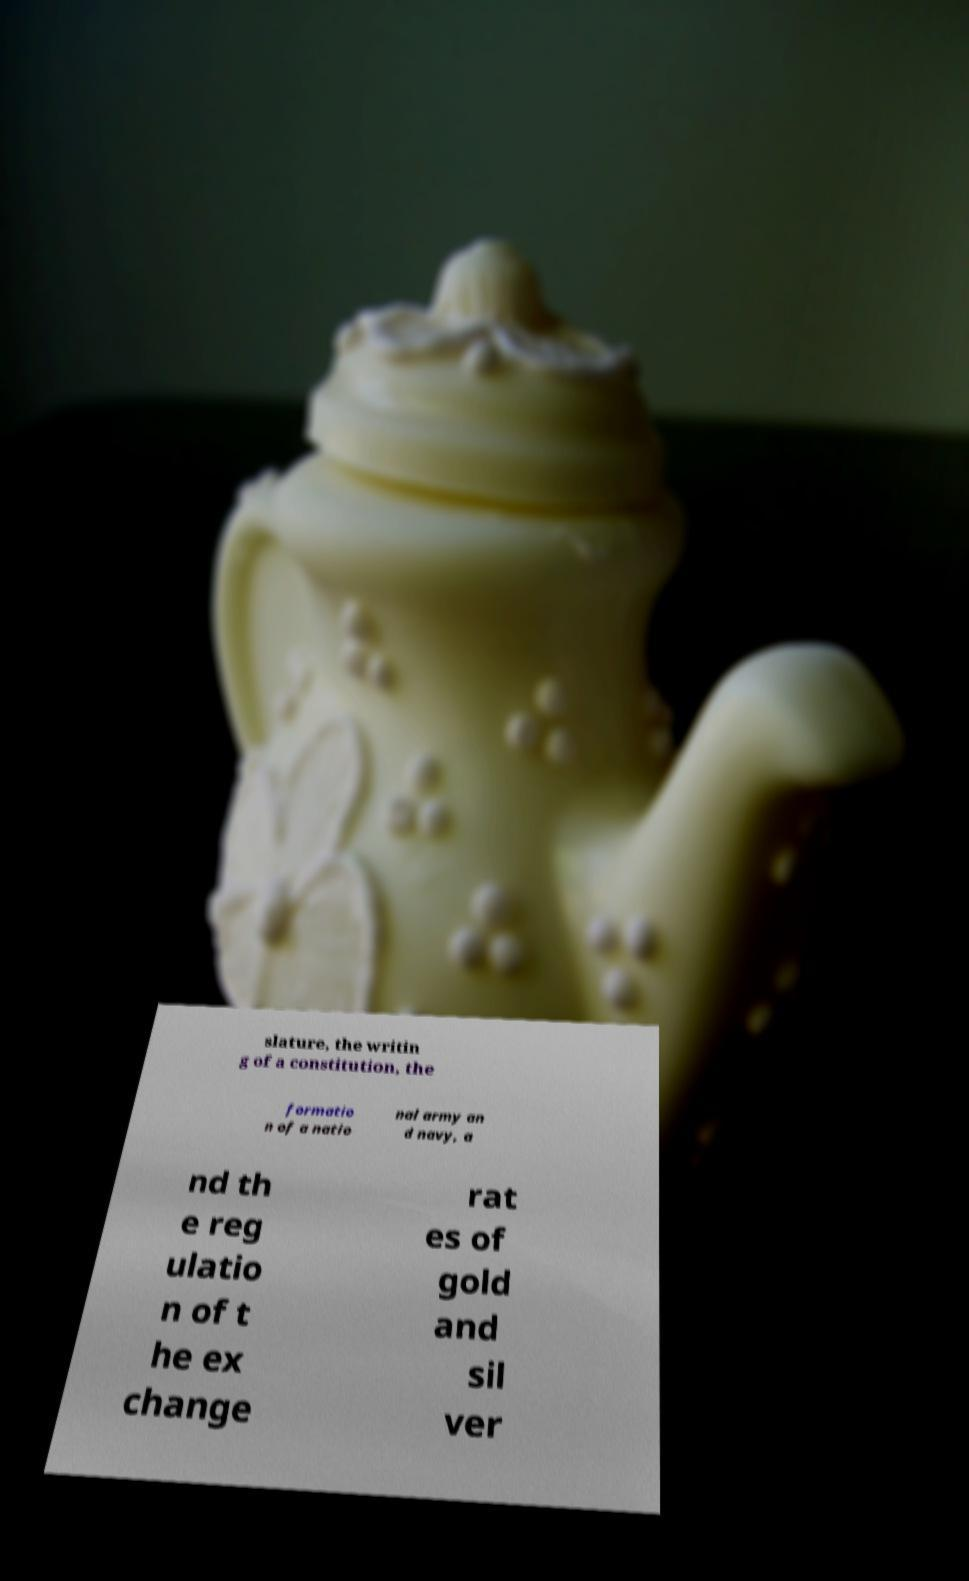There's text embedded in this image that I need extracted. Can you transcribe it verbatim? slature, the writin g of a constitution, the formatio n of a natio nal army an d navy, a nd th e reg ulatio n of t he ex change rat es of gold and sil ver 